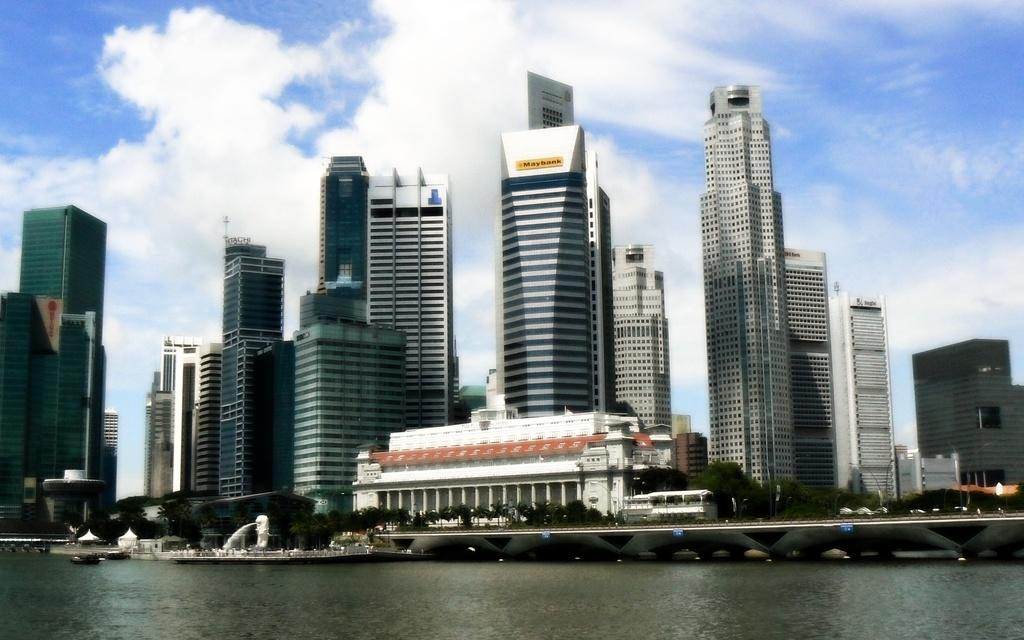What is one of the main elements in the image? There is water in the image. What other natural elements can be seen in the image? There are trees in the image. Are there any man-made structures visible? Yes, there are buildings in the image. What can be seen in the background of the image? The sky is visible in the background of the image, and clouds are present in the sky. What type of cord is being used to hang the dress in the image? There is no dress or cord present in the image. 